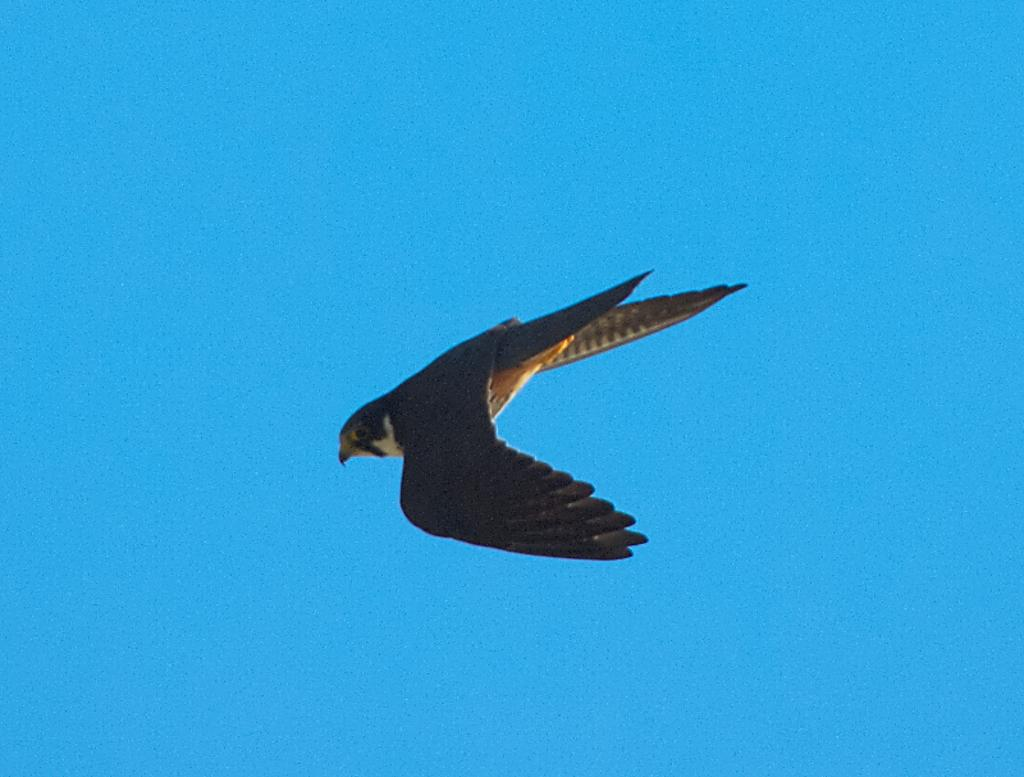What type of animal can be seen in the image? There is a bird in the image. Where is the bird located in the image? The bird is in the air. What color is the background of the image? The background of the image is blue. What type of cracker is the bird holding in its beak in the image? There is no cracker present in the image; the bird is simply flying in the air. 